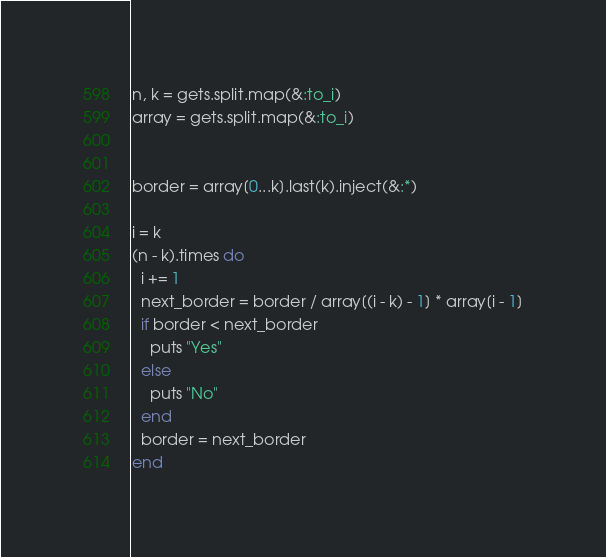<code> <loc_0><loc_0><loc_500><loc_500><_Ruby_>n, k = gets.split.map(&:to_i)
array = gets.split.map(&:to_i)


border = array[0...k].last(k).inject(&:*)

i = k
(n - k).times do
  i += 1
  next_border = border / array[(i - k) - 1] * array[i - 1]
  if border < next_border
    puts "Yes"
  else
    puts "No"
  end
  border = next_border
end
</code> 